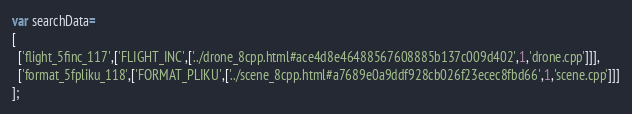<code> <loc_0><loc_0><loc_500><loc_500><_JavaScript_>var searchData=
[
  ['flight_5finc_117',['FLIGHT_INC',['../drone_8cpp.html#ace4d8e46488567608885b137c009d402',1,'drone.cpp']]],
  ['format_5fpliku_118',['FORMAT_PLIKU',['../scene_8cpp.html#a7689e0a9ddf928cb026f23ecec8fbd66',1,'scene.cpp']]]
];
</code> 